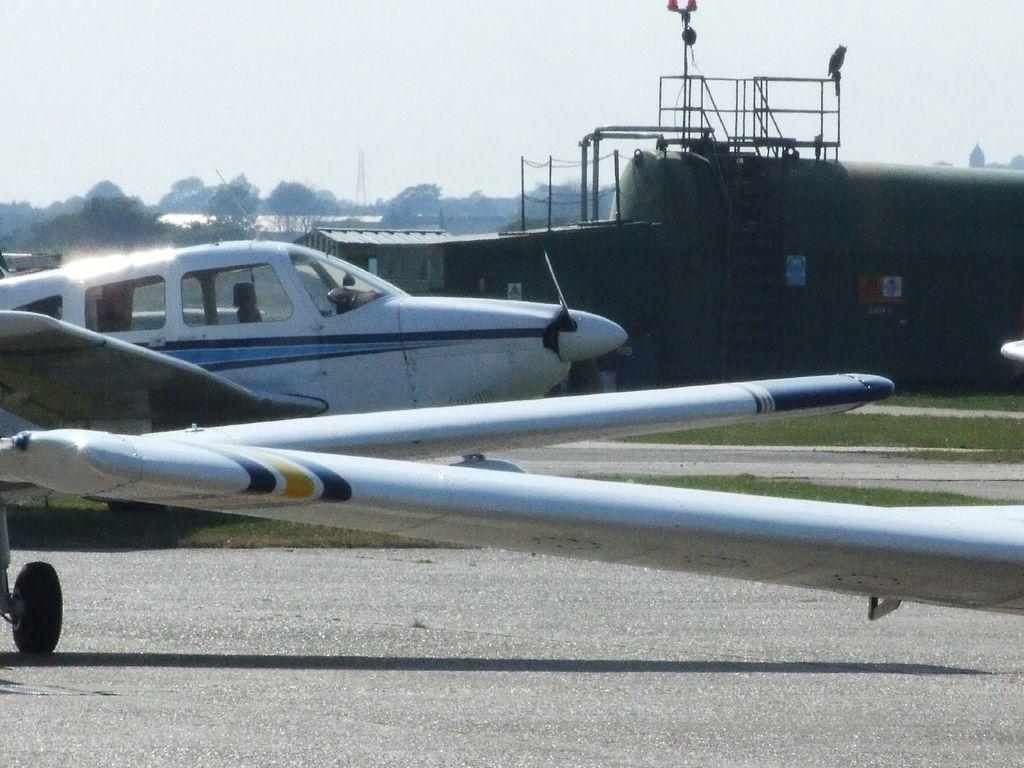Can you describe this image briefly? In this image I can see few aircraft on the road. In the background I can see the shed, many trees, tower and the sky. 